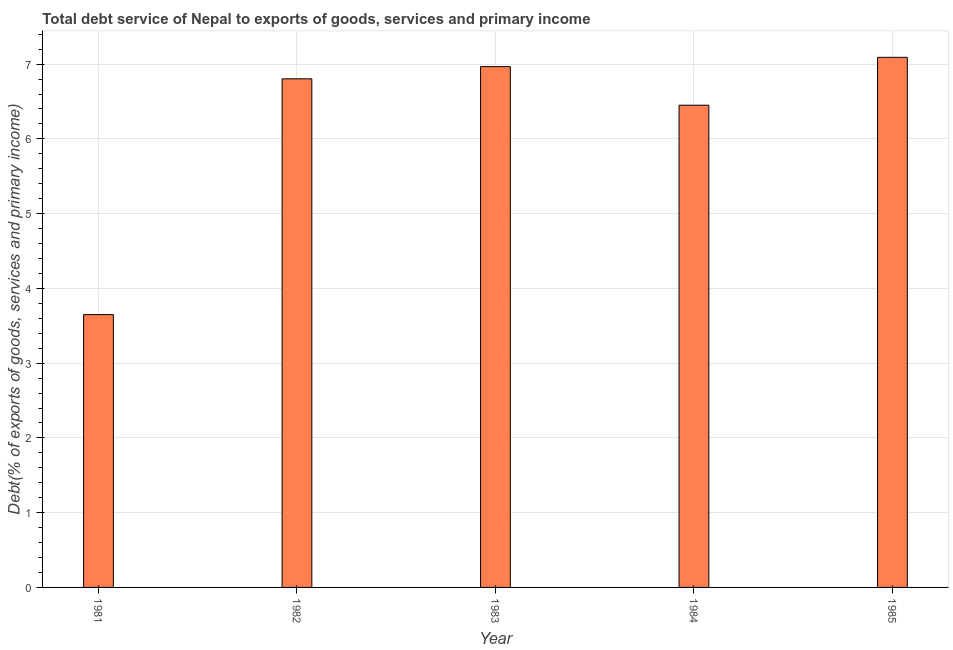Does the graph contain any zero values?
Offer a very short reply. No. Does the graph contain grids?
Make the answer very short. Yes. What is the title of the graph?
Your response must be concise. Total debt service of Nepal to exports of goods, services and primary income. What is the label or title of the X-axis?
Your answer should be compact. Year. What is the label or title of the Y-axis?
Keep it short and to the point. Debt(% of exports of goods, services and primary income). What is the total debt service in 1981?
Your response must be concise. 3.65. Across all years, what is the maximum total debt service?
Offer a terse response. 7.09. Across all years, what is the minimum total debt service?
Make the answer very short. 3.65. What is the sum of the total debt service?
Ensure brevity in your answer.  30.96. What is the difference between the total debt service in 1983 and 1985?
Provide a short and direct response. -0.12. What is the average total debt service per year?
Keep it short and to the point. 6.19. What is the median total debt service?
Provide a succinct answer. 6.8. In how many years, is the total debt service greater than 3.6 %?
Offer a very short reply. 5. What is the ratio of the total debt service in 1981 to that in 1985?
Your answer should be compact. 0.52. Is the difference between the total debt service in 1981 and 1983 greater than the difference between any two years?
Your response must be concise. No. What is the difference between the highest and the second highest total debt service?
Make the answer very short. 0.12. Is the sum of the total debt service in 1982 and 1983 greater than the maximum total debt service across all years?
Keep it short and to the point. Yes. What is the difference between the highest and the lowest total debt service?
Offer a very short reply. 3.44. In how many years, is the total debt service greater than the average total debt service taken over all years?
Your response must be concise. 4. What is the difference between two consecutive major ticks on the Y-axis?
Your answer should be very brief. 1. Are the values on the major ticks of Y-axis written in scientific E-notation?
Ensure brevity in your answer.  No. What is the Debt(% of exports of goods, services and primary income) in 1981?
Ensure brevity in your answer.  3.65. What is the Debt(% of exports of goods, services and primary income) in 1982?
Give a very brief answer. 6.8. What is the Debt(% of exports of goods, services and primary income) of 1983?
Your answer should be very brief. 6.97. What is the Debt(% of exports of goods, services and primary income) of 1984?
Make the answer very short. 6.45. What is the Debt(% of exports of goods, services and primary income) in 1985?
Keep it short and to the point. 7.09. What is the difference between the Debt(% of exports of goods, services and primary income) in 1981 and 1982?
Provide a short and direct response. -3.15. What is the difference between the Debt(% of exports of goods, services and primary income) in 1981 and 1983?
Your answer should be compact. -3.32. What is the difference between the Debt(% of exports of goods, services and primary income) in 1981 and 1984?
Give a very brief answer. -2.8. What is the difference between the Debt(% of exports of goods, services and primary income) in 1981 and 1985?
Provide a succinct answer. -3.44. What is the difference between the Debt(% of exports of goods, services and primary income) in 1982 and 1983?
Ensure brevity in your answer.  -0.16. What is the difference between the Debt(% of exports of goods, services and primary income) in 1982 and 1984?
Keep it short and to the point. 0.35. What is the difference between the Debt(% of exports of goods, services and primary income) in 1982 and 1985?
Give a very brief answer. -0.29. What is the difference between the Debt(% of exports of goods, services and primary income) in 1983 and 1984?
Offer a terse response. 0.52. What is the difference between the Debt(% of exports of goods, services and primary income) in 1983 and 1985?
Give a very brief answer. -0.12. What is the difference between the Debt(% of exports of goods, services and primary income) in 1984 and 1985?
Ensure brevity in your answer.  -0.64. What is the ratio of the Debt(% of exports of goods, services and primary income) in 1981 to that in 1982?
Provide a succinct answer. 0.54. What is the ratio of the Debt(% of exports of goods, services and primary income) in 1981 to that in 1983?
Your answer should be compact. 0.52. What is the ratio of the Debt(% of exports of goods, services and primary income) in 1981 to that in 1984?
Your response must be concise. 0.57. What is the ratio of the Debt(% of exports of goods, services and primary income) in 1981 to that in 1985?
Provide a succinct answer. 0.52. What is the ratio of the Debt(% of exports of goods, services and primary income) in 1982 to that in 1983?
Offer a very short reply. 0.98. What is the ratio of the Debt(% of exports of goods, services and primary income) in 1982 to that in 1984?
Give a very brief answer. 1.05. What is the ratio of the Debt(% of exports of goods, services and primary income) in 1982 to that in 1985?
Give a very brief answer. 0.96. What is the ratio of the Debt(% of exports of goods, services and primary income) in 1983 to that in 1984?
Your answer should be compact. 1.08. What is the ratio of the Debt(% of exports of goods, services and primary income) in 1983 to that in 1985?
Make the answer very short. 0.98. What is the ratio of the Debt(% of exports of goods, services and primary income) in 1984 to that in 1985?
Give a very brief answer. 0.91. 